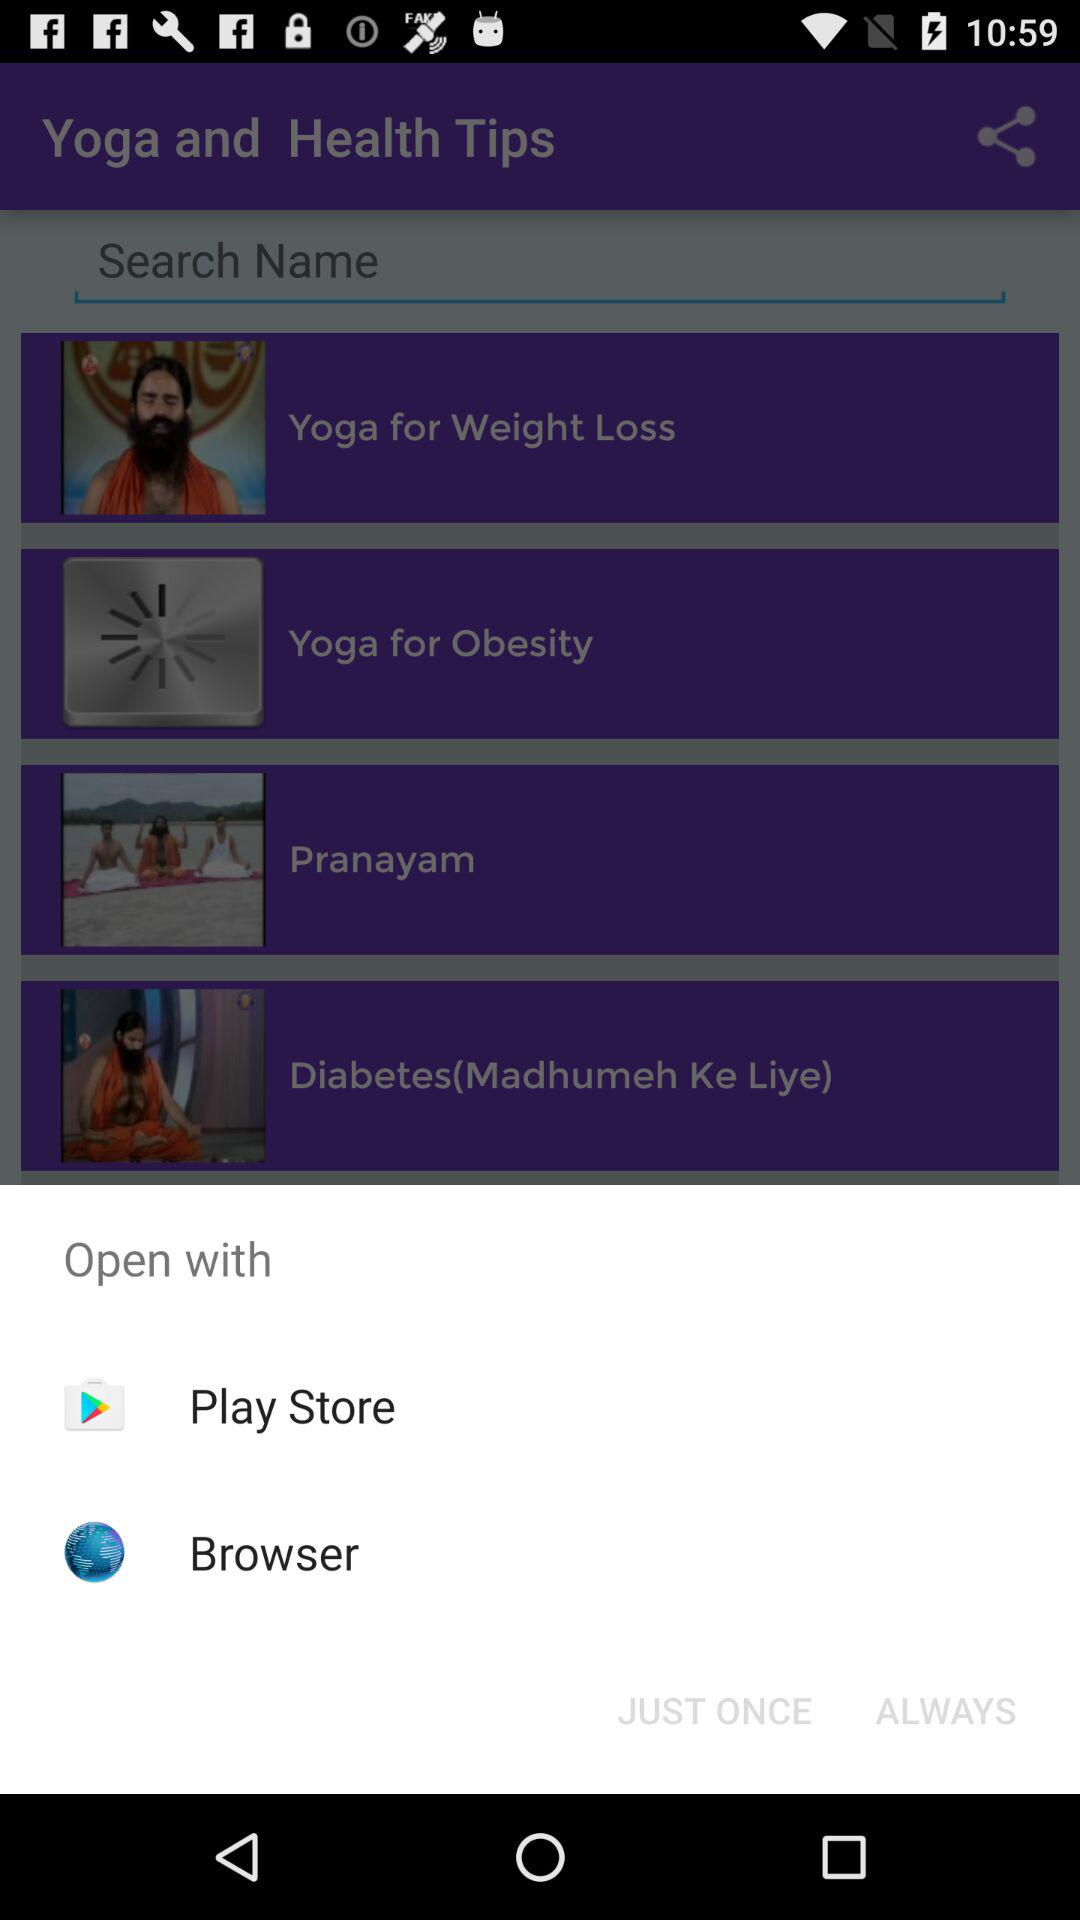How much is the yoga application?
When the provided information is insufficient, respond with <no answer>. <no answer> 